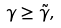Convert formula to latex. <formula><loc_0><loc_0><loc_500><loc_500>\gamma \geq \tilde { \gamma } ,</formula> 